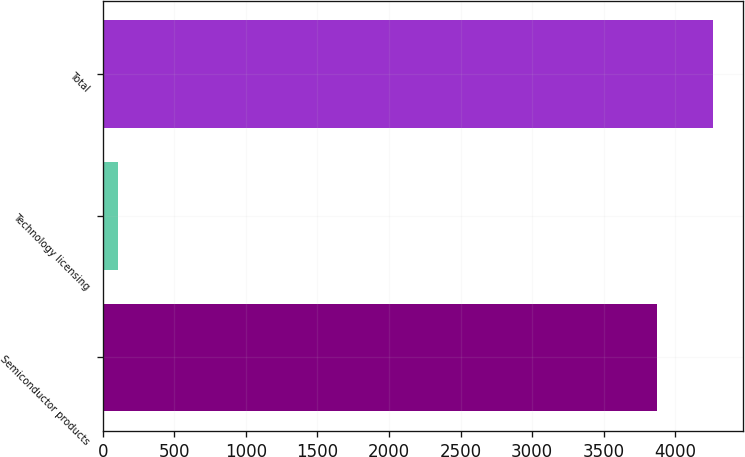<chart> <loc_0><loc_0><loc_500><loc_500><bar_chart><fcel>Semiconductor products<fcel>Technology licensing<fcel>Total<nl><fcel>3876<fcel>104.8<fcel>4263.6<nl></chart> 